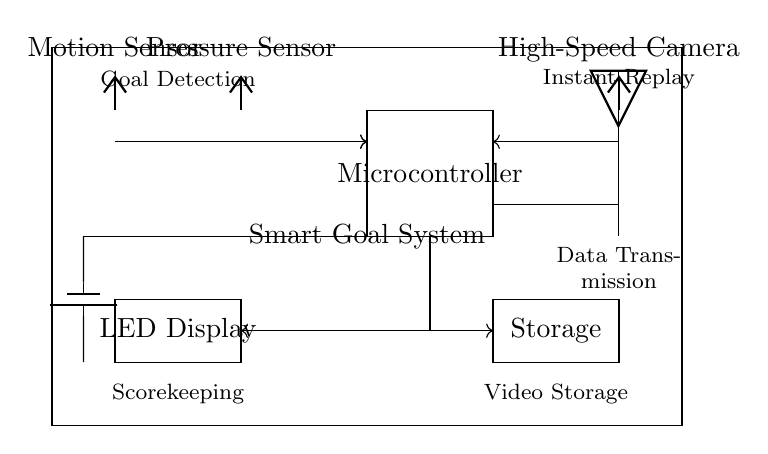What are the main components of the smart goal system? The main components include a motion sensor, pressure sensor, microcontroller, high-speed camera, LED display, storage, and a wireless module. They are all visually represented in the circuit diagram.
Answer: motion sensor, pressure sensor, microcontroller, high-speed camera, LED display, storage, wireless module How is power supplied to the smart goal system? Power is provided by a battery, as indicated by the battery symbol in the diagram that connects to the circuit and supplies voltage.
Answer: battery What function does the microcontroller serve in this circuit? The microcontroller processes data from the sensors and controls the overall operations of the smart goal system based on that data.
Answer: control and processing What type of data is transmitted wirelessly? Video data is transmitted wirelessly, as indicated by the connection from the storage to the wireless module, which is connected to the high-speed camera.
Answer: video data Where is the instant replay feature implemented in the circuit? The instant replay feature is implemented through the high-speed camera, which captures the moments and stores the video for review after a goal is scored.
Answer: high-speed camera How is the scorekeeping function achieved in this system? The scorekeeping is achieved through the integration of the microcontroller that receives input from both the motion sensor and pressure sensor to determine when a goal has been scored.
Answer: microcontroller 